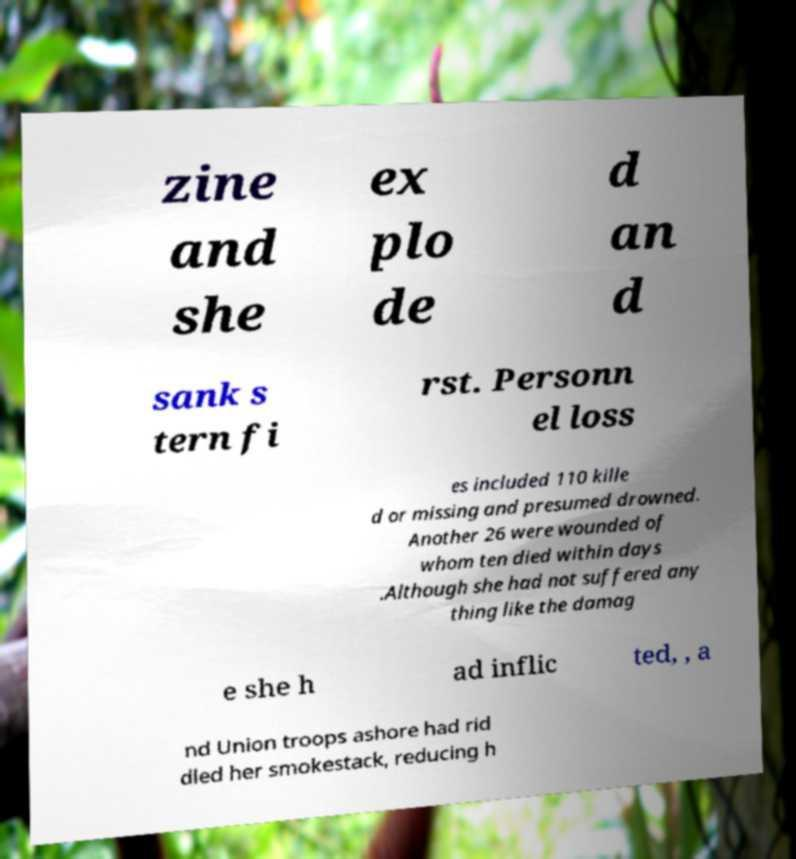Please identify and transcribe the text found in this image. zine and she ex plo de d an d sank s tern fi rst. Personn el loss es included 110 kille d or missing and presumed drowned. Another 26 were wounded of whom ten died within days .Although she had not suffered any thing like the damag e she h ad inflic ted, , a nd Union troops ashore had rid dled her smokestack, reducing h 